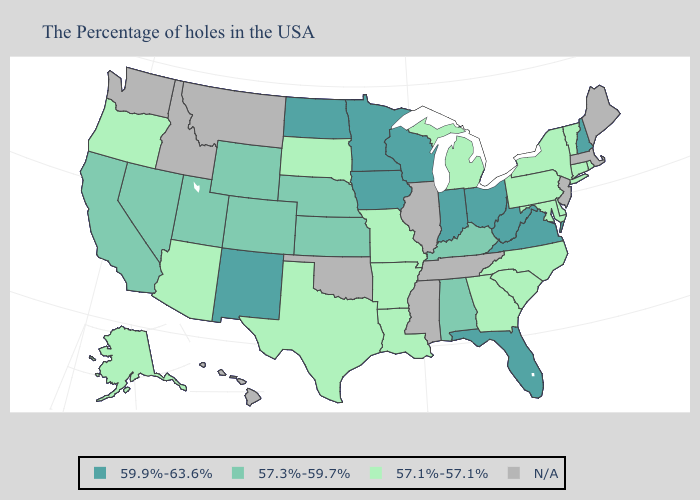Which states have the highest value in the USA?
Be succinct. New Hampshire, Virginia, West Virginia, Ohio, Florida, Indiana, Wisconsin, Minnesota, Iowa, North Dakota, New Mexico. What is the value of Alaska?
Short answer required. 57.1%-57.1%. Name the states that have a value in the range N/A?
Write a very short answer. Maine, Massachusetts, New Jersey, Tennessee, Illinois, Mississippi, Oklahoma, Montana, Idaho, Washington, Hawaii. Among the states that border Missouri , does Iowa have the highest value?
Write a very short answer. Yes. Which states have the lowest value in the South?
Give a very brief answer. Delaware, Maryland, North Carolina, South Carolina, Georgia, Louisiana, Arkansas, Texas. Which states hav the highest value in the MidWest?
Short answer required. Ohio, Indiana, Wisconsin, Minnesota, Iowa, North Dakota. Name the states that have a value in the range 59.9%-63.6%?
Quick response, please. New Hampshire, Virginia, West Virginia, Ohio, Florida, Indiana, Wisconsin, Minnesota, Iowa, North Dakota, New Mexico. What is the value of Pennsylvania?
Give a very brief answer. 57.1%-57.1%. Name the states that have a value in the range 57.3%-59.7%?
Concise answer only. Kentucky, Alabama, Kansas, Nebraska, Wyoming, Colorado, Utah, Nevada, California. Name the states that have a value in the range 57.3%-59.7%?
Short answer required. Kentucky, Alabama, Kansas, Nebraska, Wyoming, Colorado, Utah, Nevada, California. Which states hav the highest value in the South?
Write a very short answer. Virginia, West Virginia, Florida. What is the value of Delaware?
Be succinct. 57.1%-57.1%. 